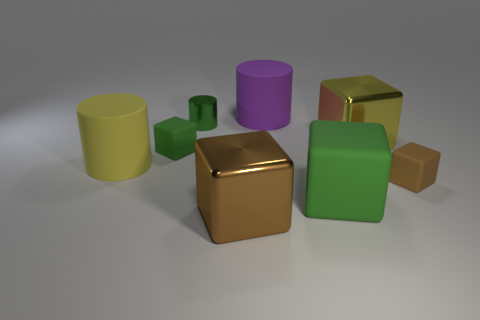Are there any objects that could be described as having a matte finish? Yes, the green cube and green cylinder have a softer, less reflective surface that suggests a matte finish. 